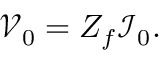Convert formula to latex. <formula><loc_0><loc_0><loc_500><loc_500>\mathcal { V } _ { 0 } = Z _ { f } \mathcal { I } _ { 0 } .</formula> 